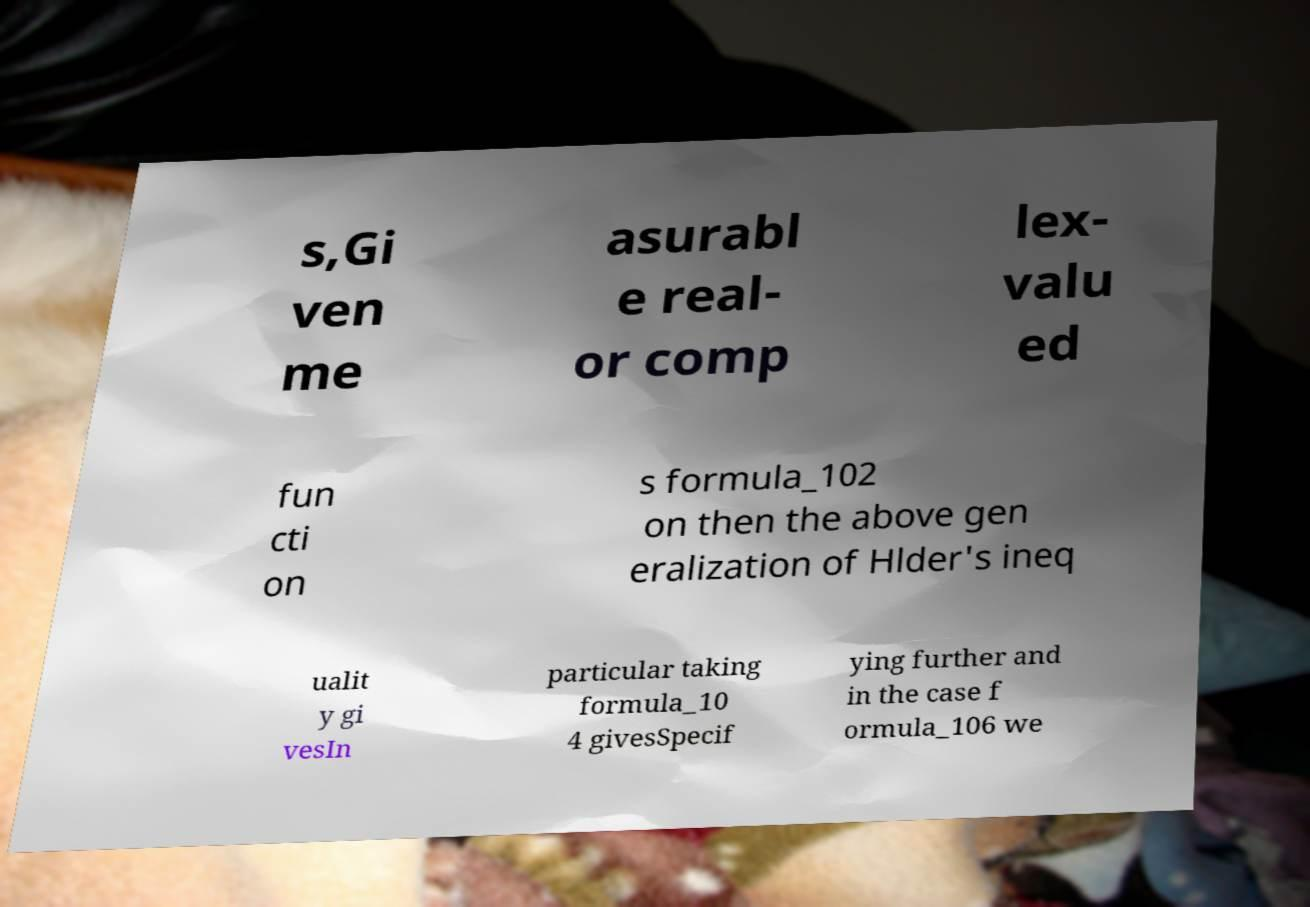Can you accurately transcribe the text from the provided image for me? s,Gi ven me asurabl e real- or comp lex- valu ed fun cti on s formula_102 on then the above gen eralization of Hlder's ineq ualit y gi vesIn particular taking formula_10 4 givesSpecif ying further and in the case f ormula_106 we 